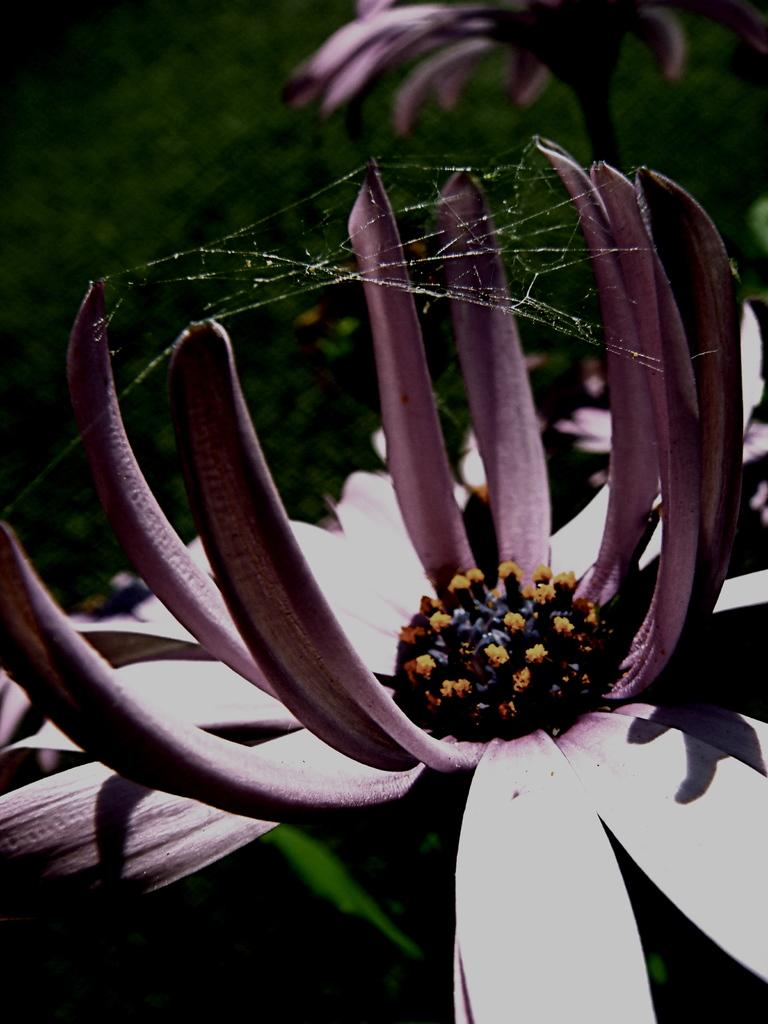How many flowers can be seen in the image? There are two flowers in the image. What can be seen in the background of the image? There is greenery in the background of the image. What type of toothbrush is being used to clean the flowers in the image? There is no toothbrush present in the image, and the flowers are not being cleaned. 